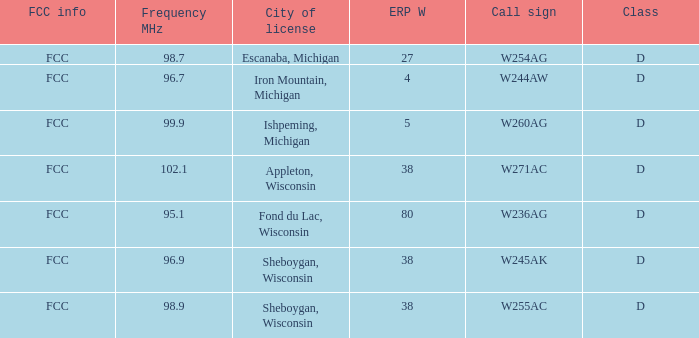What was the class for Appleton, Wisconsin? D. 